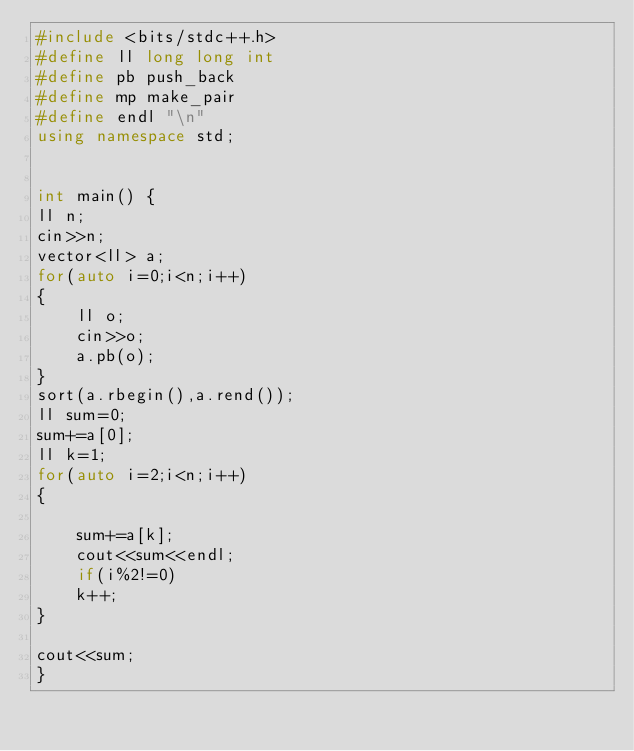<code> <loc_0><loc_0><loc_500><loc_500><_C++_>#include <bits/stdc++.h>
#define ll long long int
#define pb push_back
#define mp make_pair
#define endl "\n"
using namespace std;


int main() {
ll n;
cin>>n;
vector<ll> a;
for(auto i=0;i<n;i++)
{
    ll o;
    cin>>o;
    a.pb(o);
}
sort(a.rbegin(),a.rend());
ll sum=0;
sum+=a[0];
ll k=1;
for(auto i=2;i<n;i++)
{

    sum+=a[k];
    cout<<sum<<endl;
    if(i%2!=0)
    k++;
}

cout<<sum;
}</code> 